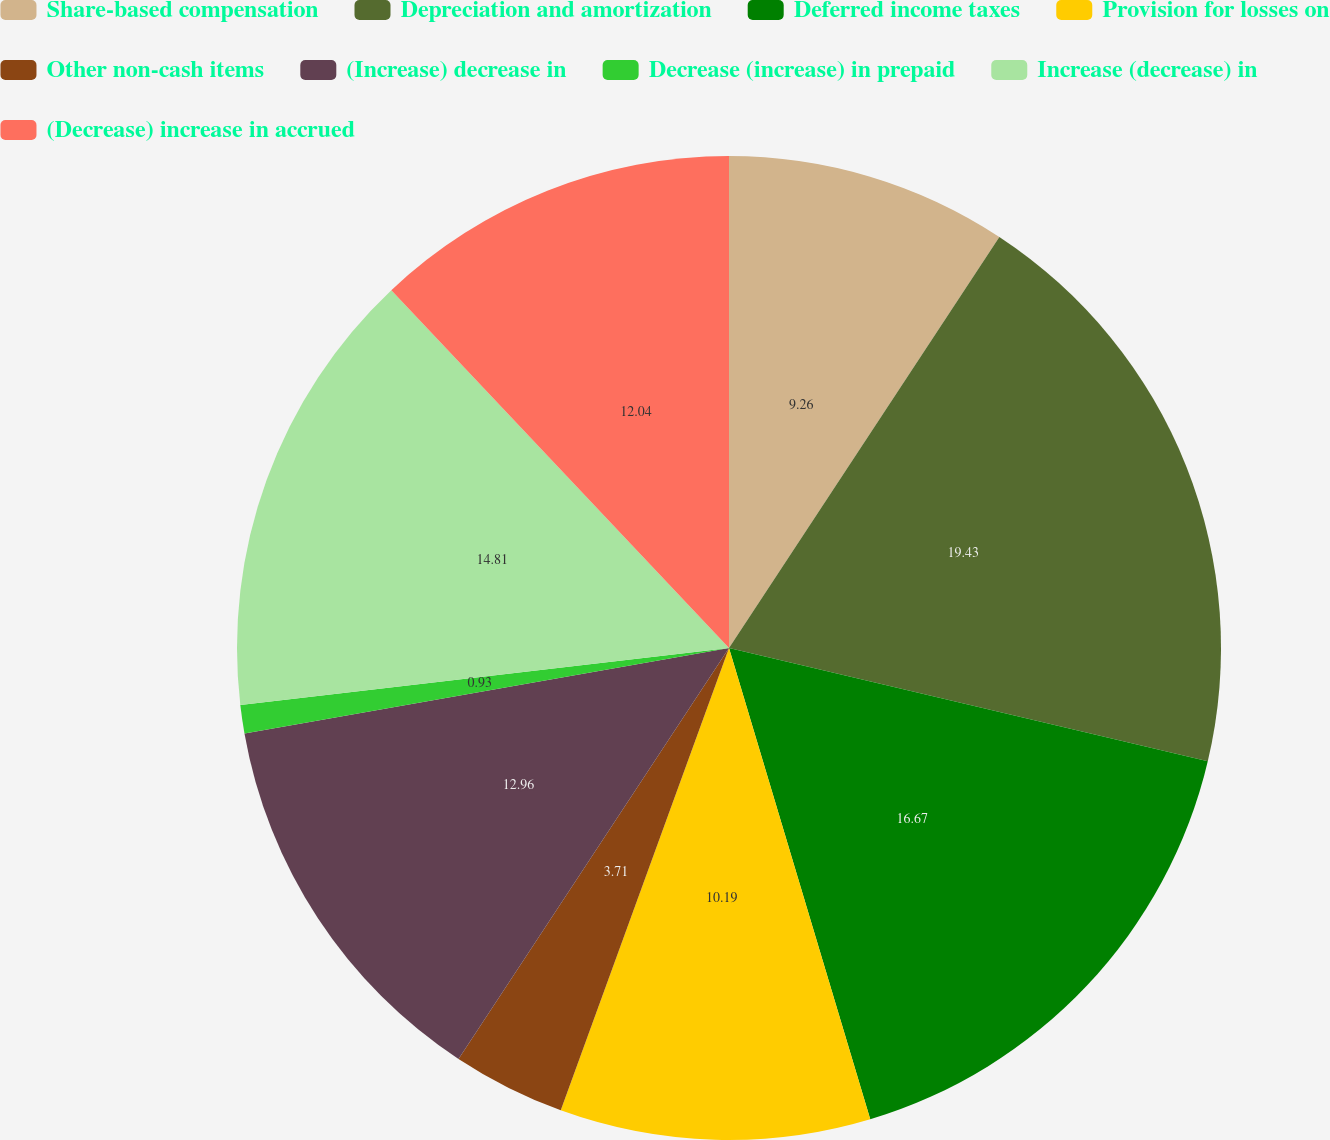<chart> <loc_0><loc_0><loc_500><loc_500><pie_chart><fcel>Share-based compensation<fcel>Depreciation and amortization<fcel>Deferred income taxes<fcel>Provision for losses on<fcel>Other non-cash items<fcel>(Increase) decrease in<fcel>Decrease (increase) in prepaid<fcel>Increase (decrease) in<fcel>(Decrease) increase in accrued<nl><fcel>9.26%<fcel>19.44%<fcel>16.67%<fcel>10.19%<fcel>3.71%<fcel>12.96%<fcel>0.93%<fcel>14.81%<fcel>12.04%<nl></chart> 